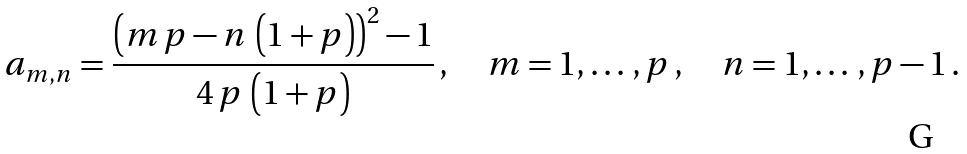<formula> <loc_0><loc_0><loc_500><loc_500>a _ { m , n } = \frac { { \left ( m \, p - n \, \left ( 1 + p \right ) \right ) } ^ { 2 } - 1 } { 4 \, p \, \left ( 1 + p \right ) } \, , \quad m = 1 , \dots \, , p \, , \quad n = 1 , \dots \, , p - 1 \, .</formula> 